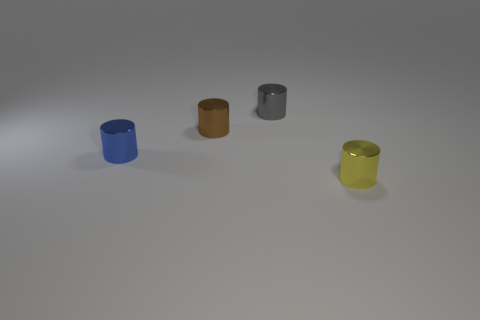Can you describe the lighting in this scene? The scene is softly lit from above, creating gentle shadows beneath the objects, suggesting an indirect or diffused light source. 